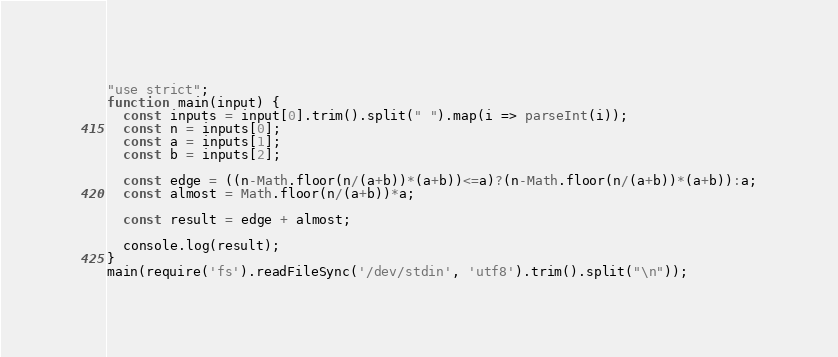Convert code to text. <code><loc_0><loc_0><loc_500><loc_500><_JavaScript_>"use strict";
function main(input) {
  const inputs = input[0].trim().split(" ").map(i => parseInt(i));
  const n = inputs[0];
  const a = inputs[1];
  const b = inputs[2];

  const edge = ((n-Math.floor(n/(a+b))*(a+b))<=a)?(n-Math.floor(n/(a+b))*(a+b)):a;
  const almost = Math.floor(n/(a+b))*a;

  const result = edge + almost;
  
  console.log(result);
}
main(require('fs').readFileSync('/dev/stdin', 'utf8').trim().split("\n"));</code> 